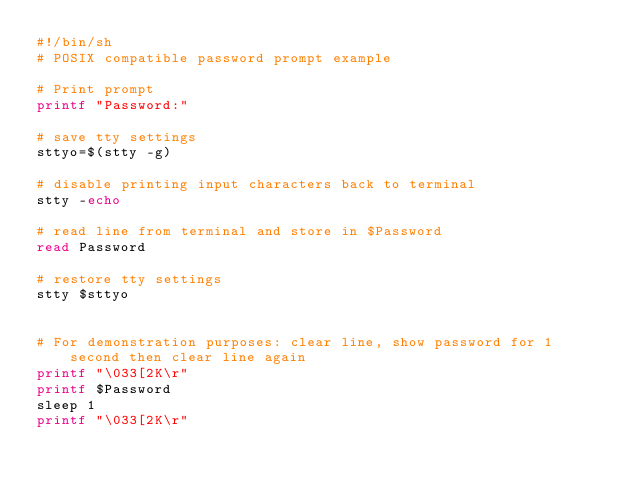Convert code to text. <code><loc_0><loc_0><loc_500><loc_500><_Bash_>#!/bin/sh
# POSIX compatible password prompt example

# Print prompt
printf "Password:"

# save tty settings
sttyo=$(stty -g)

# disable printing input characters back to terminal
stty -echo

# read line from terminal and store in $Password
read Password

# restore tty settings
stty $sttyo


# For demonstration purposes: clear line, show password for 1 second then clear line again
printf "\033[2K\r"
printf $Password
sleep 1
printf "\033[2K\r"

</code> 